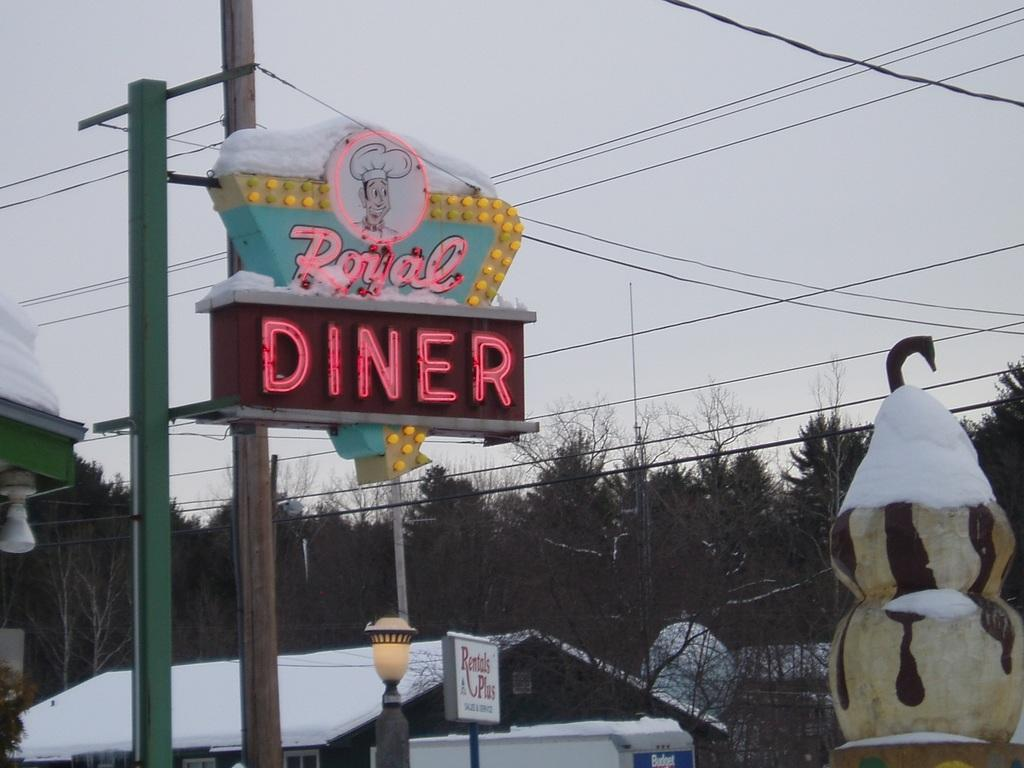What structures are located in the foreground of the picture? There are buildings, a pole, a board, and cables in the foreground of the picture. What can be seen in the middle of the picture? There are trees, snow, and a house in the middle of the picture. What is visible at the top of the picture? The sky is visible at the top of the picture. What time does the actor appear in the picture? There is no actor present in the image, so it is not possible to determine when they might appear. What type of jar can be seen on the house in the middle of the picture? There is no jar visible on the house in the middle of the picture. 